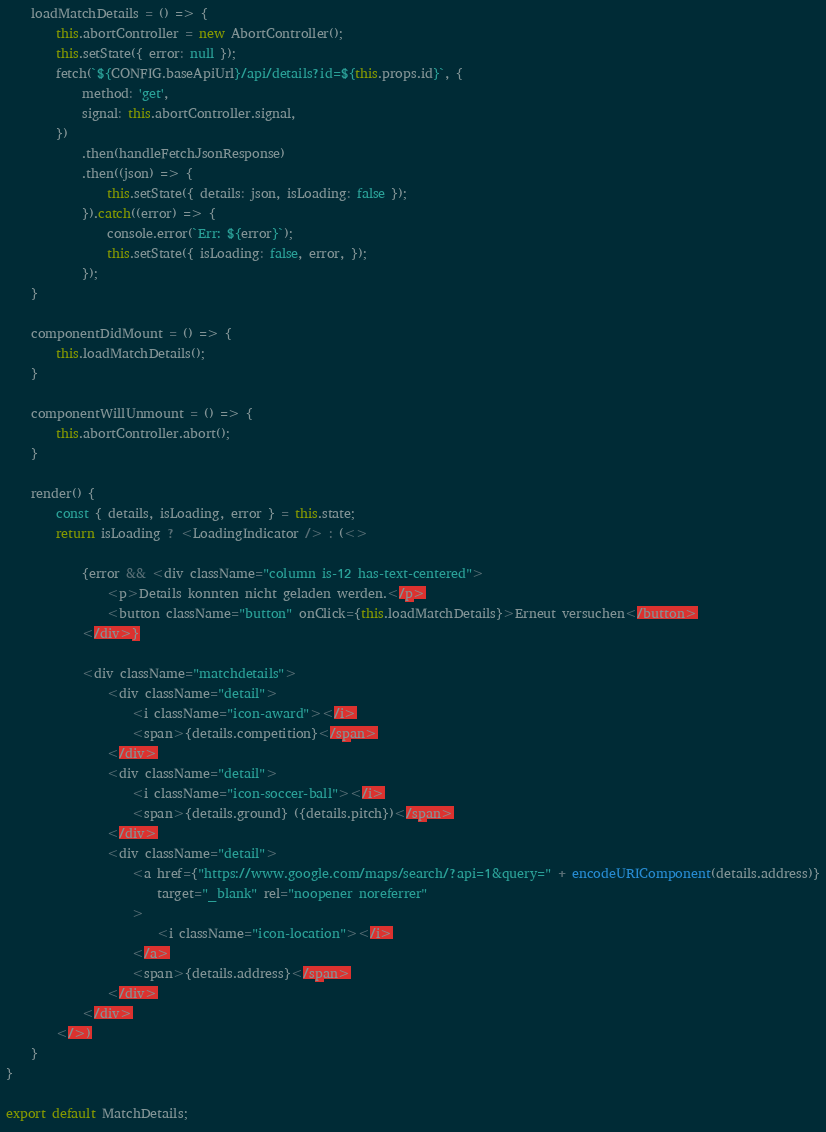<code> <loc_0><loc_0><loc_500><loc_500><_JavaScript_>    loadMatchDetails = () => {
        this.abortController = new AbortController();
        this.setState({ error: null });
        fetch(`${CONFIG.baseApiUrl}/api/details?id=${this.props.id}`, {
            method: 'get',
            signal: this.abortController.signal,
        })
            .then(handleFetchJsonResponse)
            .then((json) => {
                this.setState({ details: json, isLoading: false });
            }).catch((error) => {
                console.error(`Err: ${error}`);
                this.setState({ isLoading: false, error, });
            });
    }

    componentDidMount = () => {
        this.loadMatchDetails();
    }

    componentWillUnmount = () => {
        this.abortController.abort();
    }

    render() {
        const { details, isLoading, error } = this.state;
        return isLoading ? <LoadingIndicator /> : (<>

            {error && <div className="column is-12 has-text-centered">
                <p>Details konnten nicht geladen werden.</p>
                <button className="button" onClick={this.loadMatchDetails}>Erneut versuchen</button>
            </div>}

            <div className="matchdetails">
                <div className="detail">
                    <i className="icon-award"></i>
                    <span>{details.competition}</span>
                </div>
                <div className="detail">
                    <i className="icon-soccer-ball"></i>
                    <span>{details.ground} ({details.pitch})</span>
                </div>
                <div className="detail">
                    <a href={"https://www.google.com/maps/search/?api=1&query=" + encodeURIComponent(details.address)}
                        target="_blank" rel="noopener noreferrer"
                    >
                        <i className="icon-location"></i>
                    </a>
                    <span>{details.address}</span>
                </div>
            </div>
        </>)
    }
}

export default MatchDetails;
</code> 